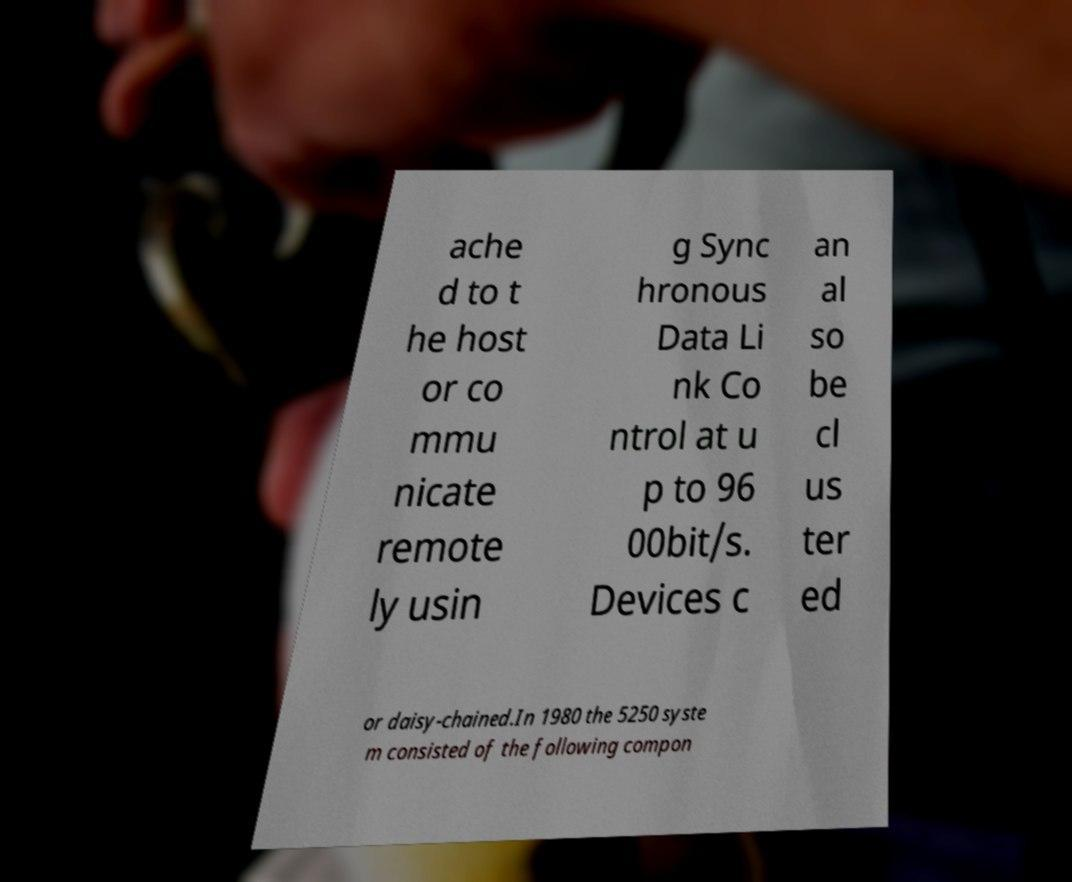There's text embedded in this image that I need extracted. Can you transcribe it verbatim? ache d to t he host or co mmu nicate remote ly usin g Sync hronous Data Li nk Co ntrol at u p to 96 00bit/s. Devices c an al so be cl us ter ed or daisy-chained.In 1980 the 5250 syste m consisted of the following compon 